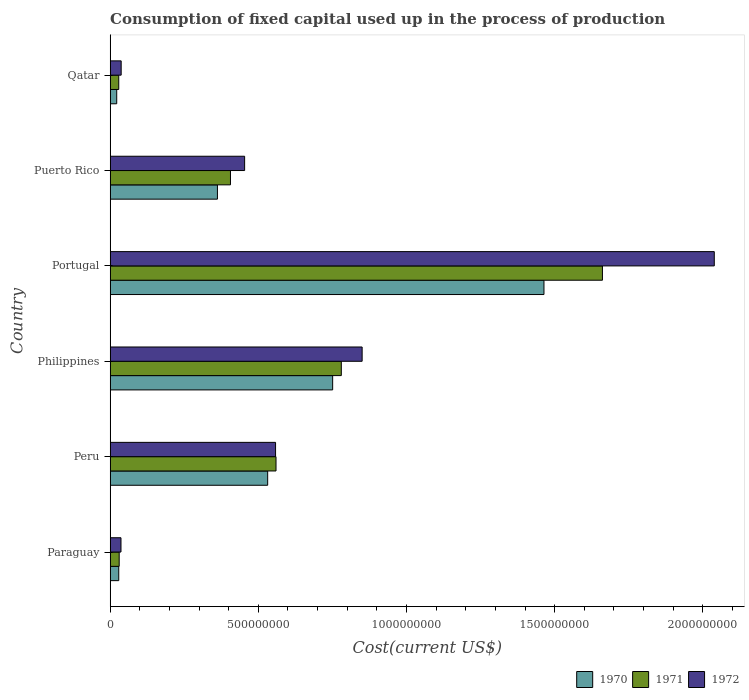How many different coloured bars are there?
Your response must be concise. 3. How many groups of bars are there?
Provide a succinct answer. 6. What is the label of the 1st group of bars from the top?
Provide a short and direct response. Qatar. In how many cases, is the number of bars for a given country not equal to the number of legend labels?
Your answer should be compact. 0. What is the amount consumed in the process of production in 1970 in Paraguay?
Provide a short and direct response. 2.90e+07. Across all countries, what is the maximum amount consumed in the process of production in 1971?
Provide a short and direct response. 1.66e+09. Across all countries, what is the minimum amount consumed in the process of production in 1972?
Ensure brevity in your answer.  3.66e+07. In which country was the amount consumed in the process of production in 1971 maximum?
Make the answer very short. Portugal. In which country was the amount consumed in the process of production in 1970 minimum?
Provide a short and direct response. Qatar. What is the total amount consumed in the process of production in 1972 in the graph?
Your response must be concise. 3.97e+09. What is the difference between the amount consumed in the process of production in 1971 in Peru and that in Portugal?
Offer a terse response. -1.10e+09. What is the difference between the amount consumed in the process of production in 1972 in Peru and the amount consumed in the process of production in 1971 in Qatar?
Offer a terse response. 5.29e+08. What is the average amount consumed in the process of production in 1971 per country?
Provide a short and direct response. 5.78e+08. What is the difference between the amount consumed in the process of production in 1971 and amount consumed in the process of production in 1970 in Peru?
Give a very brief answer. 2.82e+07. In how many countries, is the amount consumed in the process of production in 1970 greater than 400000000 US$?
Offer a terse response. 3. What is the ratio of the amount consumed in the process of production in 1971 in Peru to that in Portugal?
Provide a short and direct response. 0.34. Is the difference between the amount consumed in the process of production in 1971 in Philippines and Portugal greater than the difference between the amount consumed in the process of production in 1970 in Philippines and Portugal?
Your answer should be compact. No. What is the difference between the highest and the second highest amount consumed in the process of production in 1971?
Offer a very short reply. 8.81e+08. What is the difference between the highest and the lowest amount consumed in the process of production in 1972?
Offer a very short reply. 2.00e+09. What does the 3rd bar from the top in Peru represents?
Provide a succinct answer. 1970. Is it the case that in every country, the sum of the amount consumed in the process of production in 1970 and amount consumed in the process of production in 1972 is greater than the amount consumed in the process of production in 1971?
Provide a succinct answer. Yes. Are all the bars in the graph horizontal?
Provide a short and direct response. Yes. How many countries are there in the graph?
Your response must be concise. 6. What is the difference between two consecutive major ticks on the X-axis?
Make the answer very short. 5.00e+08. Are the values on the major ticks of X-axis written in scientific E-notation?
Offer a very short reply. No. Where does the legend appear in the graph?
Keep it short and to the point. Bottom right. How many legend labels are there?
Offer a very short reply. 3. How are the legend labels stacked?
Offer a very short reply. Horizontal. What is the title of the graph?
Your response must be concise. Consumption of fixed capital used up in the process of production. What is the label or title of the X-axis?
Your answer should be very brief. Cost(current US$). What is the label or title of the Y-axis?
Make the answer very short. Country. What is the Cost(current US$) in 1970 in Paraguay?
Ensure brevity in your answer.  2.90e+07. What is the Cost(current US$) of 1971 in Paraguay?
Offer a terse response. 3.05e+07. What is the Cost(current US$) of 1972 in Paraguay?
Ensure brevity in your answer.  3.66e+07. What is the Cost(current US$) of 1970 in Peru?
Provide a succinct answer. 5.31e+08. What is the Cost(current US$) of 1971 in Peru?
Give a very brief answer. 5.60e+08. What is the Cost(current US$) in 1972 in Peru?
Provide a short and direct response. 5.58e+08. What is the Cost(current US$) in 1970 in Philippines?
Make the answer very short. 7.51e+08. What is the Cost(current US$) in 1971 in Philippines?
Your answer should be compact. 7.80e+08. What is the Cost(current US$) of 1972 in Philippines?
Ensure brevity in your answer.  8.50e+08. What is the Cost(current US$) in 1970 in Portugal?
Your response must be concise. 1.46e+09. What is the Cost(current US$) of 1971 in Portugal?
Your answer should be very brief. 1.66e+09. What is the Cost(current US$) in 1972 in Portugal?
Make the answer very short. 2.04e+09. What is the Cost(current US$) of 1970 in Puerto Rico?
Make the answer very short. 3.62e+08. What is the Cost(current US$) of 1971 in Puerto Rico?
Provide a succinct answer. 4.06e+08. What is the Cost(current US$) in 1972 in Puerto Rico?
Ensure brevity in your answer.  4.54e+08. What is the Cost(current US$) of 1970 in Qatar?
Keep it short and to the point. 2.22e+07. What is the Cost(current US$) in 1971 in Qatar?
Offer a very short reply. 2.90e+07. What is the Cost(current US$) in 1972 in Qatar?
Your response must be concise. 3.72e+07. Across all countries, what is the maximum Cost(current US$) in 1970?
Provide a short and direct response. 1.46e+09. Across all countries, what is the maximum Cost(current US$) of 1971?
Provide a short and direct response. 1.66e+09. Across all countries, what is the maximum Cost(current US$) of 1972?
Keep it short and to the point. 2.04e+09. Across all countries, what is the minimum Cost(current US$) of 1970?
Offer a terse response. 2.22e+07. Across all countries, what is the minimum Cost(current US$) of 1971?
Provide a succinct answer. 2.90e+07. Across all countries, what is the minimum Cost(current US$) in 1972?
Provide a succinct answer. 3.66e+07. What is the total Cost(current US$) in 1970 in the graph?
Your response must be concise. 3.16e+09. What is the total Cost(current US$) in 1971 in the graph?
Make the answer very short. 3.47e+09. What is the total Cost(current US$) of 1972 in the graph?
Your answer should be compact. 3.97e+09. What is the difference between the Cost(current US$) in 1970 in Paraguay and that in Peru?
Offer a terse response. -5.02e+08. What is the difference between the Cost(current US$) in 1971 in Paraguay and that in Peru?
Offer a terse response. -5.29e+08. What is the difference between the Cost(current US$) in 1972 in Paraguay and that in Peru?
Ensure brevity in your answer.  -5.22e+08. What is the difference between the Cost(current US$) in 1970 in Paraguay and that in Philippines?
Keep it short and to the point. -7.22e+08. What is the difference between the Cost(current US$) of 1971 in Paraguay and that in Philippines?
Offer a very short reply. -7.50e+08. What is the difference between the Cost(current US$) of 1972 in Paraguay and that in Philippines?
Your answer should be very brief. -8.14e+08. What is the difference between the Cost(current US$) in 1970 in Paraguay and that in Portugal?
Your answer should be very brief. -1.43e+09. What is the difference between the Cost(current US$) of 1971 in Paraguay and that in Portugal?
Your answer should be very brief. -1.63e+09. What is the difference between the Cost(current US$) in 1972 in Paraguay and that in Portugal?
Provide a short and direct response. -2.00e+09. What is the difference between the Cost(current US$) of 1970 in Paraguay and that in Puerto Rico?
Make the answer very short. -3.33e+08. What is the difference between the Cost(current US$) in 1971 in Paraguay and that in Puerto Rico?
Give a very brief answer. -3.75e+08. What is the difference between the Cost(current US$) in 1972 in Paraguay and that in Puerto Rico?
Offer a terse response. -4.17e+08. What is the difference between the Cost(current US$) in 1970 in Paraguay and that in Qatar?
Your answer should be compact. 6.83e+06. What is the difference between the Cost(current US$) in 1971 in Paraguay and that in Qatar?
Your answer should be very brief. 1.48e+06. What is the difference between the Cost(current US$) of 1972 in Paraguay and that in Qatar?
Provide a succinct answer. -6.34e+05. What is the difference between the Cost(current US$) in 1970 in Peru and that in Philippines?
Keep it short and to the point. -2.19e+08. What is the difference between the Cost(current US$) of 1971 in Peru and that in Philippines?
Provide a short and direct response. -2.20e+08. What is the difference between the Cost(current US$) in 1972 in Peru and that in Philippines?
Offer a very short reply. -2.92e+08. What is the difference between the Cost(current US$) in 1970 in Peru and that in Portugal?
Your answer should be very brief. -9.32e+08. What is the difference between the Cost(current US$) in 1971 in Peru and that in Portugal?
Your answer should be very brief. -1.10e+09. What is the difference between the Cost(current US$) of 1972 in Peru and that in Portugal?
Offer a very short reply. -1.48e+09. What is the difference between the Cost(current US$) in 1970 in Peru and that in Puerto Rico?
Provide a short and direct response. 1.70e+08. What is the difference between the Cost(current US$) in 1971 in Peru and that in Puerto Rico?
Keep it short and to the point. 1.54e+08. What is the difference between the Cost(current US$) of 1972 in Peru and that in Puerto Rico?
Offer a very short reply. 1.04e+08. What is the difference between the Cost(current US$) in 1970 in Peru and that in Qatar?
Make the answer very short. 5.09e+08. What is the difference between the Cost(current US$) in 1971 in Peru and that in Qatar?
Keep it short and to the point. 5.31e+08. What is the difference between the Cost(current US$) in 1972 in Peru and that in Qatar?
Provide a succinct answer. 5.21e+08. What is the difference between the Cost(current US$) of 1970 in Philippines and that in Portugal?
Ensure brevity in your answer.  -7.13e+08. What is the difference between the Cost(current US$) in 1971 in Philippines and that in Portugal?
Offer a very short reply. -8.81e+08. What is the difference between the Cost(current US$) in 1972 in Philippines and that in Portugal?
Give a very brief answer. -1.19e+09. What is the difference between the Cost(current US$) in 1970 in Philippines and that in Puerto Rico?
Give a very brief answer. 3.89e+08. What is the difference between the Cost(current US$) of 1971 in Philippines and that in Puerto Rico?
Provide a short and direct response. 3.74e+08. What is the difference between the Cost(current US$) in 1972 in Philippines and that in Puerto Rico?
Ensure brevity in your answer.  3.96e+08. What is the difference between the Cost(current US$) in 1970 in Philippines and that in Qatar?
Give a very brief answer. 7.29e+08. What is the difference between the Cost(current US$) of 1971 in Philippines and that in Qatar?
Your answer should be very brief. 7.51e+08. What is the difference between the Cost(current US$) of 1972 in Philippines and that in Qatar?
Your answer should be compact. 8.13e+08. What is the difference between the Cost(current US$) in 1970 in Portugal and that in Puerto Rico?
Provide a short and direct response. 1.10e+09. What is the difference between the Cost(current US$) of 1971 in Portugal and that in Puerto Rico?
Keep it short and to the point. 1.26e+09. What is the difference between the Cost(current US$) in 1972 in Portugal and that in Puerto Rico?
Give a very brief answer. 1.58e+09. What is the difference between the Cost(current US$) in 1970 in Portugal and that in Qatar?
Make the answer very short. 1.44e+09. What is the difference between the Cost(current US$) of 1971 in Portugal and that in Qatar?
Provide a short and direct response. 1.63e+09. What is the difference between the Cost(current US$) in 1972 in Portugal and that in Qatar?
Provide a succinct answer. 2.00e+09. What is the difference between the Cost(current US$) in 1970 in Puerto Rico and that in Qatar?
Your answer should be very brief. 3.40e+08. What is the difference between the Cost(current US$) of 1971 in Puerto Rico and that in Qatar?
Your answer should be very brief. 3.77e+08. What is the difference between the Cost(current US$) of 1972 in Puerto Rico and that in Qatar?
Offer a very short reply. 4.17e+08. What is the difference between the Cost(current US$) of 1970 in Paraguay and the Cost(current US$) of 1971 in Peru?
Give a very brief answer. -5.31e+08. What is the difference between the Cost(current US$) of 1970 in Paraguay and the Cost(current US$) of 1972 in Peru?
Provide a succinct answer. -5.29e+08. What is the difference between the Cost(current US$) in 1971 in Paraguay and the Cost(current US$) in 1972 in Peru?
Make the answer very short. -5.28e+08. What is the difference between the Cost(current US$) in 1970 in Paraguay and the Cost(current US$) in 1971 in Philippines?
Keep it short and to the point. -7.51e+08. What is the difference between the Cost(current US$) in 1970 in Paraguay and the Cost(current US$) in 1972 in Philippines?
Ensure brevity in your answer.  -8.21e+08. What is the difference between the Cost(current US$) of 1971 in Paraguay and the Cost(current US$) of 1972 in Philippines?
Keep it short and to the point. -8.20e+08. What is the difference between the Cost(current US$) of 1970 in Paraguay and the Cost(current US$) of 1971 in Portugal?
Offer a terse response. -1.63e+09. What is the difference between the Cost(current US$) in 1970 in Paraguay and the Cost(current US$) in 1972 in Portugal?
Offer a very short reply. -2.01e+09. What is the difference between the Cost(current US$) of 1971 in Paraguay and the Cost(current US$) of 1972 in Portugal?
Keep it short and to the point. -2.01e+09. What is the difference between the Cost(current US$) of 1970 in Paraguay and the Cost(current US$) of 1971 in Puerto Rico?
Give a very brief answer. -3.77e+08. What is the difference between the Cost(current US$) of 1970 in Paraguay and the Cost(current US$) of 1972 in Puerto Rico?
Offer a terse response. -4.25e+08. What is the difference between the Cost(current US$) of 1971 in Paraguay and the Cost(current US$) of 1972 in Puerto Rico?
Keep it short and to the point. -4.23e+08. What is the difference between the Cost(current US$) in 1970 in Paraguay and the Cost(current US$) in 1971 in Qatar?
Keep it short and to the point. 2.56e+04. What is the difference between the Cost(current US$) of 1970 in Paraguay and the Cost(current US$) of 1972 in Qatar?
Offer a very short reply. -8.17e+06. What is the difference between the Cost(current US$) in 1971 in Paraguay and the Cost(current US$) in 1972 in Qatar?
Make the answer very short. -6.71e+06. What is the difference between the Cost(current US$) of 1970 in Peru and the Cost(current US$) of 1971 in Philippines?
Give a very brief answer. -2.48e+08. What is the difference between the Cost(current US$) of 1970 in Peru and the Cost(current US$) of 1972 in Philippines?
Your answer should be very brief. -3.19e+08. What is the difference between the Cost(current US$) in 1971 in Peru and the Cost(current US$) in 1972 in Philippines?
Keep it short and to the point. -2.91e+08. What is the difference between the Cost(current US$) in 1970 in Peru and the Cost(current US$) in 1971 in Portugal?
Offer a very short reply. -1.13e+09. What is the difference between the Cost(current US$) in 1970 in Peru and the Cost(current US$) in 1972 in Portugal?
Offer a terse response. -1.51e+09. What is the difference between the Cost(current US$) in 1971 in Peru and the Cost(current US$) in 1972 in Portugal?
Provide a short and direct response. -1.48e+09. What is the difference between the Cost(current US$) in 1970 in Peru and the Cost(current US$) in 1971 in Puerto Rico?
Offer a very short reply. 1.26e+08. What is the difference between the Cost(current US$) of 1970 in Peru and the Cost(current US$) of 1972 in Puerto Rico?
Provide a succinct answer. 7.77e+07. What is the difference between the Cost(current US$) in 1971 in Peru and the Cost(current US$) in 1972 in Puerto Rico?
Provide a succinct answer. 1.06e+08. What is the difference between the Cost(current US$) of 1970 in Peru and the Cost(current US$) of 1971 in Qatar?
Provide a short and direct response. 5.02e+08. What is the difference between the Cost(current US$) of 1970 in Peru and the Cost(current US$) of 1972 in Qatar?
Your response must be concise. 4.94e+08. What is the difference between the Cost(current US$) of 1971 in Peru and the Cost(current US$) of 1972 in Qatar?
Make the answer very short. 5.22e+08. What is the difference between the Cost(current US$) in 1970 in Philippines and the Cost(current US$) in 1971 in Portugal?
Your answer should be compact. -9.10e+08. What is the difference between the Cost(current US$) in 1970 in Philippines and the Cost(current US$) in 1972 in Portugal?
Provide a succinct answer. -1.29e+09. What is the difference between the Cost(current US$) of 1971 in Philippines and the Cost(current US$) of 1972 in Portugal?
Offer a very short reply. -1.26e+09. What is the difference between the Cost(current US$) of 1970 in Philippines and the Cost(current US$) of 1971 in Puerto Rico?
Offer a terse response. 3.45e+08. What is the difference between the Cost(current US$) in 1970 in Philippines and the Cost(current US$) in 1972 in Puerto Rico?
Offer a very short reply. 2.97e+08. What is the difference between the Cost(current US$) in 1971 in Philippines and the Cost(current US$) in 1972 in Puerto Rico?
Your answer should be very brief. 3.26e+08. What is the difference between the Cost(current US$) in 1970 in Philippines and the Cost(current US$) in 1971 in Qatar?
Your response must be concise. 7.22e+08. What is the difference between the Cost(current US$) of 1970 in Philippines and the Cost(current US$) of 1972 in Qatar?
Your answer should be compact. 7.14e+08. What is the difference between the Cost(current US$) of 1971 in Philippines and the Cost(current US$) of 1972 in Qatar?
Provide a succinct answer. 7.43e+08. What is the difference between the Cost(current US$) in 1970 in Portugal and the Cost(current US$) in 1971 in Puerto Rico?
Offer a very short reply. 1.06e+09. What is the difference between the Cost(current US$) in 1970 in Portugal and the Cost(current US$) in 1972 in Puerto Rico?
Your answer should be compact. 1.01e+09. What is the difference between the Cost(current US$) in 1971 in Portugal and the Cost(current US$) in 1972 in Puerto Rico?
Keep it short and to the point. 1.21e+09. What is the difference between the Cost(current US$) in 1970 in Portugal and the Cost(current US$) in 1971 in Qatar?
Your answer should be very brief. 1.43e+09. What is the difference between the Cost(current US$) of 1970 in Portugal and the Cost(current US$) of 1972 in Qatar?
Offer a terse response. 1.43e+09. What is the difference between the Cost(current US$) of 1971 in Portugal and the Cost(current US$) of 1972 in Qatar?
Your answer should be very brief. 1.62e+09. What is the difference between the Cost(current US$) in 1970 in Puerto Rico and the Cost(current US$) in 1971 in Qatar?
Give a very brief answer. 3.33e+08. What is the difference between the Cost(current US$) in 1970 in Puerto Rico and the Cost(current US$) in 1972 in Qatar?
Your answer should be compact. 3.25e+08. What is the difference between the Cost(current US$) of 1971 in Puerto Rico and the Cost(current US$) of 1972 in Qatar?
Your answer should be compact. 3.69e+08. What is the average Cost(current US$) in 1970 per country?
Ensure brevity in your answer.  5.27e+08. What is the average Cost(current US$) in 1971 per country?
Provide a short and direct response. 5.78e+08. What is the average Cost(current US$) of 1972 per country?
Offer a terse response. 6.62e+08. What is the difference between the Cost(current US$) of 1970 and Cost(current US$) of 1971 in Paraguay?
Your response must be concise. -1.46e+06. What is the difference between the Cost(current US$) in 1970 and Cost(current US$) in 1972 in Paraguay?
Offer a terse response. -7.54e+06. What is the difference between the Cost(current US$) in 1971 and Cost(current US$) in 1972 in Paraguay?
Offer a very short reply. -6.08e+06. What is the difference between the Cost(current US$) of 1970 and Cost(current US$) of 1971 in Peru?
Your answer should be compact. -2.82e+07. What is the difference between the Cost(current US$) in 1970 and Cost(current US$) in 1972 in Peru?
Offer a terse response. -2.66e+07. What is the difference between the Cost(current US$) in 1971 and Cost(current US$) in 1972 in Peru?
Offer a very short reply. 1.53e+06. What is the difference between the Cost(current US$) of 1970 and Cost(current US$) of 1971 in Philippines?
Your answer should be very brief. -2.92e+07. What is the difference between the Cost(current US$) of 1970 and Cost(current US$) of 1972 in Philippines?
Provide a succinct answer. -9.95e+07. What is the difference between the Cost(current US$) of 1971 and Cost(current US$) of 1972 in Philippines?
Ensure brevity in your answer.  -7.02e+07. What is the difference between the Cost(current US$) in 1970 and Cost(current US$) in 1971 in Portugal?
Give a very brief answer. -1.97e+08. What is the difference between the Cost(current US$) in 1970 and Cost(current US$) in 1972 in Portugal?
Make the answer very short. -5.75e+08. What is the difference between the Cost(current US$) of 1971 and Cost(current US$) of 1972 in Portugal?
Make the answer very short. -3.77e+08. What is the difference between the Cost(current US$) in 1970 and Cost(current US$) in 1971 in Puerto Rico?
Keep it short and to the point. -4.40e+07. What is the difference between the Cost(current US$) of 1970 and Cost(current US$) of 1972 in Puerto Rico?
Give a very brief answer. -9.18e+07. What is the difference between the Cost(current US$) of 1971 and Cost(current US$) of 1972 in Puerto Rico?
Give a very brief answer. -4.78e+07. What is the difference between the Cost(current US$) of 1970 and Cost(current US$) of 1971 in Qatar?
Offer a very short reply. -6.81e+06. What is the difference between the Cost(current US$) of 1970 and Cost(current US$) of 1972 in Qatar?
Give a very brief answer. -1.50e+07. What is the difference between the Cost(current US$) of 1971 and Cost(current US$) of 1972 in Qatar?
Provide a short and direct response. -8.20e+06. What is the ratio of the Cost(current US$) of 1970 in Paraguay to that in Peru?
Keep it short and to the point. 0.05. What is the ratio of the Cost(current US$) of 1971 in Paraguay to that in Peru?
Your response must be concise. 0.05. What is the ratio of the Cost(current US$) in 1972 in Paraguay to that in Peru?
Offer a terse response. 0.07. What is the ratio of the Cost(current US$) in 1970 in Paraguay to that in Philippines?
Offer a terse response. 0.04. What is the ratio of the Cost(current US$) in 1971 in Paraguay to that in Philippines?
Provide a succinct answer. 0.04. What is the ratio of the Cost(current US$) of 1972 in Paraguay to that in Philippines?
Provide a short and direct response. 0.04. What is the ratio of the Cost(current US$) in 1970 in Paraguay to that in Portugal?
Your response must be concise. 0.02. What is the ratio of the Cost(current US$) of 1971 in Paraguay to that in Portugal?
Your answer should be very brief. 0.02. What is the ratio of the Cost(current US$) in 1972 in Paraguay to that in Portugal?
Provide a succinct answer. 0.02. What is the ratio of the Cost(current US$) in 1970 in Paraguay to that in Puerto Rico?
Your response must be concise. 0.08. What is the ratio of the Cost(current US$) in 1971 in Paraguay to that in Puerto Rico?
Provide a short and direct response. 0.08. What is the ratio of the Cost(current US$) in 1972 in Paraguay to that in Puerto Rico?
Offer a very short reply. 0.08. What is the ratio of the Cost(current US$) of 1970 in Paraguay to that in Qatar?
Make the answer very short. 1.31. What is the ratio of the Cost(current US$) in 1971 in Paraguay to that in Qatar?
Give a very brief answer. 1.05. What is the ratio of the Cost(current US$) in 1972 in Paraguay to that in Qatar?
Keep it short and to the point. 0.98. What is the ratio of the Cost(current US$) in 1970 in Peru to that in Philippines?
Offer a very short reply. 0.71. What is the ratio of the Cost(current US$) in 1971 in Peru to that in Philippines?
Ensure brevity in your answer.  0.72. What is the ratio of the Cost(current US$) in 1972 in Peru to that in Philippines?
Provide a short and direct response. 0.66. What is the ratio of the Cost(current US$) in 1970 in Peru to that in Portugal?
Provide a short and direct response. 0.36. What is the ratio of the Cost(current US$) in 1971 in Peru to that in Portugal?
Provide a short and direct response. 0.34. What is the ratio of the Cost(current US$) in 1972 in Peru to that in Portugal?
Give a very brief answer. 0.27. What is the ratio of the Cost(current US$) in 1970 in Peru to that in Puerto Rico?
Ensure brevity in your answer.  1.47. What is the ratio of the Cost(current US$) of 1971 in Peru to that in Puerto Rico?
Your response must be concise. 1.38. What is the ratio of the Cost(current US$) of 1972 in Peru to that in Puerto Rico?
Ensure brevity in your answer.  1.23. What is the ratio of the Cost(current US$) of 1970 in Peru to that in Qatar?
Ensure brevity in your answer.  23.95. What is the ratio of the Cost(current US$) of 1971 in Peru to that in Qatar?
Your answer should be compact. 19.3. What is the ratio of the Cost(current US$) of 1972 in Peru to that in Qatar?
Make the answer very short. 15.01. What is the ratio of the Cost(current US$) of 1970 in Philippines to that in Portugal?
Keep it short and to the point. 0.51. What is the ratio of the Cost(current US$) in 1971 in Philippines to that in Portugal?
Your response must be concise. 0.47. What is the ratio of the Cost(current US$) in 1972 in Philippines to that in Portugal?
Ensure brevity in your answer.  0.42. What is the ratio of the Cost(current US$) of 1970 in Philippines to that in Puerto Rico?
Your answer should be very brief. 2.07. What is the ratio of the Cost(current US$) of 1971 in Philippines to that in Puerto Rico?
Give a very brief answer. 1.92. What is the ratio of the Cost(current US$) in 1972 in Philippines to that in Puerto Rico?
Make the answer very short. 1.87. What is the ratio of the Cost(current US$) of 1970 in Philippines to that in Qatar?
Offer a very short reply. 33.84. What is the ratio of the Cost(current US$) in 1971 in Philippines to that in Qatar?
Make the answer very short. 26.9. What is the ratio of the Cost(current US$) of 1972 in Philippines to that in Qatar?
Keep it short and to the point. 22.86. What is the ratio of the Cost(current US$) in 1970 in Portugal to that in Puerto Rico?
Keep it short and to the point. 4.04. What is the ratio of the Cost(current US$) in 1971 in Portugal to that in Puerto Rico?
Keep it short and to the point. 4.09. What is the ratio of the Cost(current US$) in 1972 in Portugal to that in Puerto Rico?
Keep it short and to the point. 4.49. What is the ratio of the Cost(current US$) in 1970 in Portugal to that in Qatar?
Provide a succinct answer. 65.97. What is the ratio of the Cost(current US$) of 1971 in Portugal to that in Qatar?
Your response must be concise. 57.29. What is the ratio of the Cost(current US$) of 1972 in Portugal to that in Qatar?
Offer a terse response. 54.81. What is the ratio of the Cost(current US$) in 1970 in Puerto Rico to that in Qatar?
Provide a succinct answer. 16.31. What is the ratio of the Cost(current US$) of 1971 in Puerto Rico to that in Qatar?
Ensure brevity in your answer.  14. What is the ratio of the Cost(current US$) in 1972 in Puerto Rico to that in Qatar?
Ensure brevity in your answer.  12.2. What is the difference between the highest and the second highest Cost(current US$) of 1970?
Offer a terse response. 7.13e+08. What is the difference between the highest and the second highest Cost(current US$) of 1971?
Offer a terse response. 8.81e+08. What is the difference between the highest and the second highest Cost(current US$) in 1972?
Offer a very short reply. 1.19e+09. What is the difference between the highest and the lowest Cost(current US$) of 1970?
Give a very brief answer. 1.44e+09. What is the difference between the highest and the lowest Cost(current US$) in 1971?
Provide a short and direct response. 1.63e+09. What is the difference between the highest and the lowest Cost(current US$) of 1972?
Offer a very short reply. 2.00e+09. 